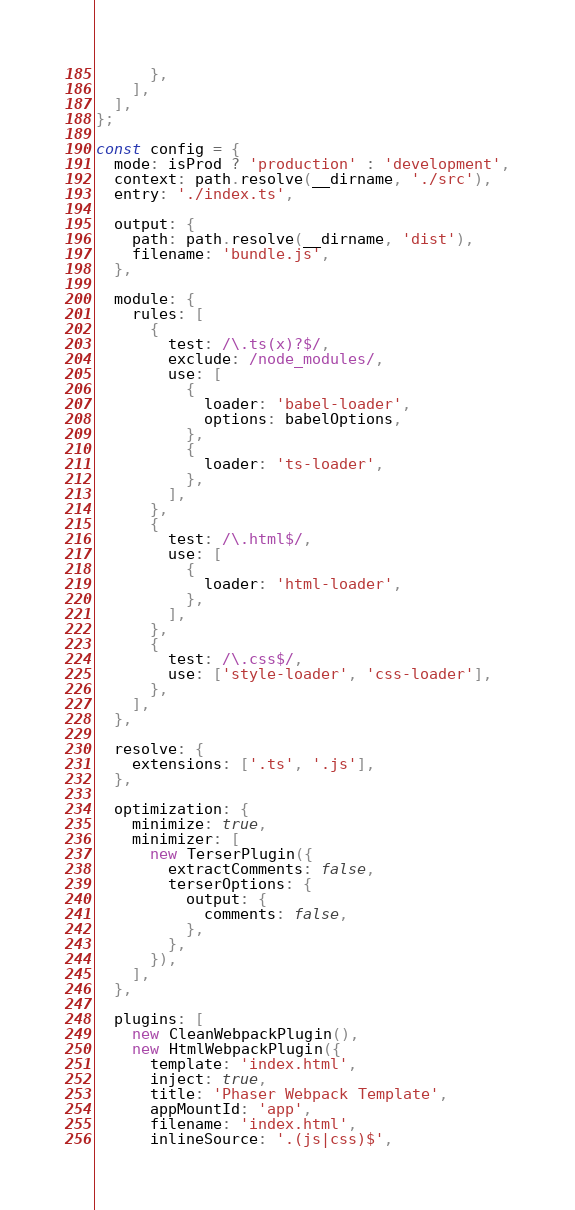Convert code to text. <code><loc_0><loc_0><loc_500><loc_500><_JavaScript_>      },
    ],
  ],
};

const config = {
  mode: isProd ? 'production' : 'development',
  context: path.resolve(__dirname, './src'),
  entry: './index.ts',

  output: {
    path: path.resolve(__dirname, 'dist'),
    filename: 'bundle.js',
  },

  module: {
    rules: [
      {
        test: /\.ts(x)?$/,
        exclude: /node_modules/,
        use: [
          {
            loader: 'babel-loader',
            options: babelOptions,
          },
          {
            loader: 'ts-loader',
          },
        ],
      },
      {
        test: /\.html$/,
        use: [
          {
            loader: 'html-loader',
          },
        ],
      },
      {
        test: /\.css$/,
        use: ['style-loader', 'css-loader'],
      },
    ],
  },

  resolve: {
    extensions: ['.ts', '.js'],
  },

  optimization: {
    minimize: true,
    minimizer: [
      new TerserPlugin({
        extractComments: false,
        terserOptions: {
          output: {
            comments: false,
          },
        },
      }),
    ],
  },

  plugins: [
    new CleanWebpackPlugin(),
    new HtmlWebpackPlugin({
      template: 'index.html',
      inject: true,
      title: 'Phaser Webpack Template',
      appMountId: 'app',
      filename: 'index.html',
      inlineSource: '.(js|css)$',</code> 